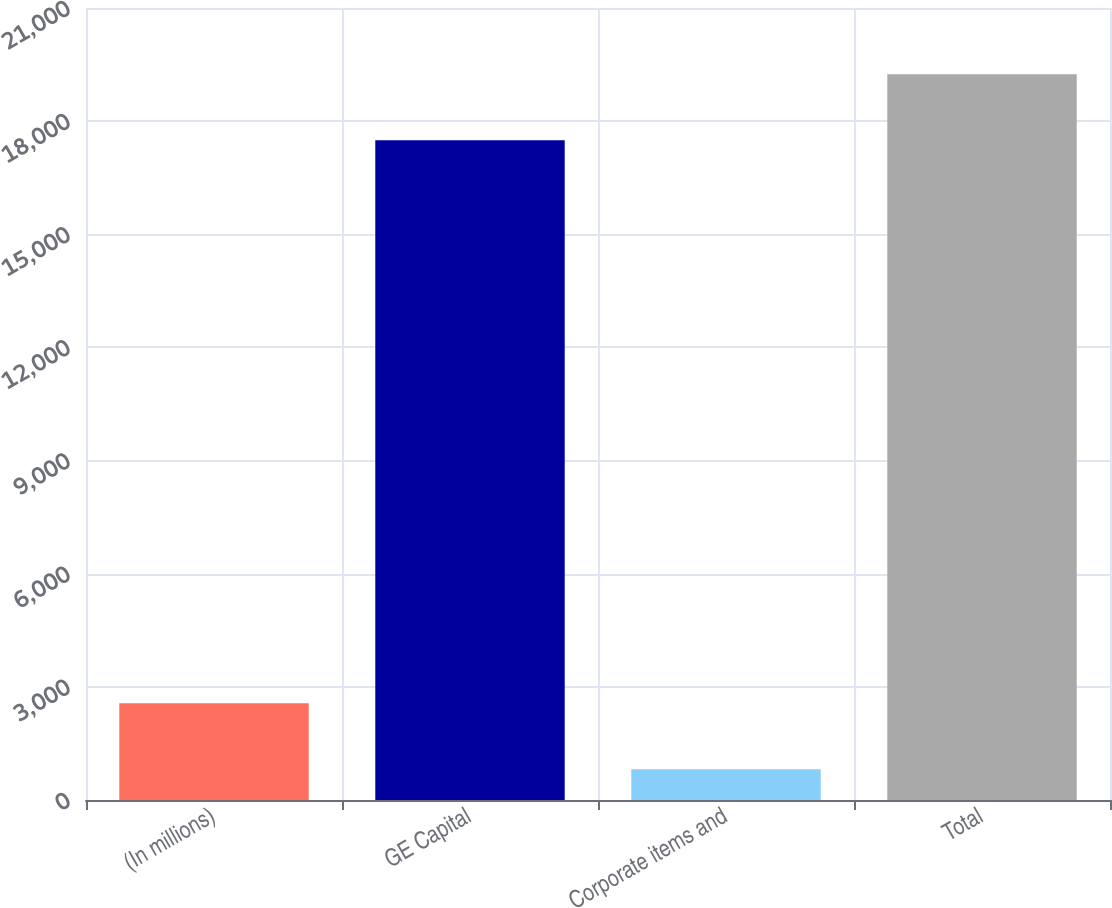Convert chart. <chart><loc_0><loc_0><loc_500><loc_500><bar_chart><fcel>(In millions)<fcel>GE Capital<fcel>Corporate items and<fcel>Total<nl><fcel>2567.1<fcel>17491<fcel>818<fcel>19240.1<nl></chart> 